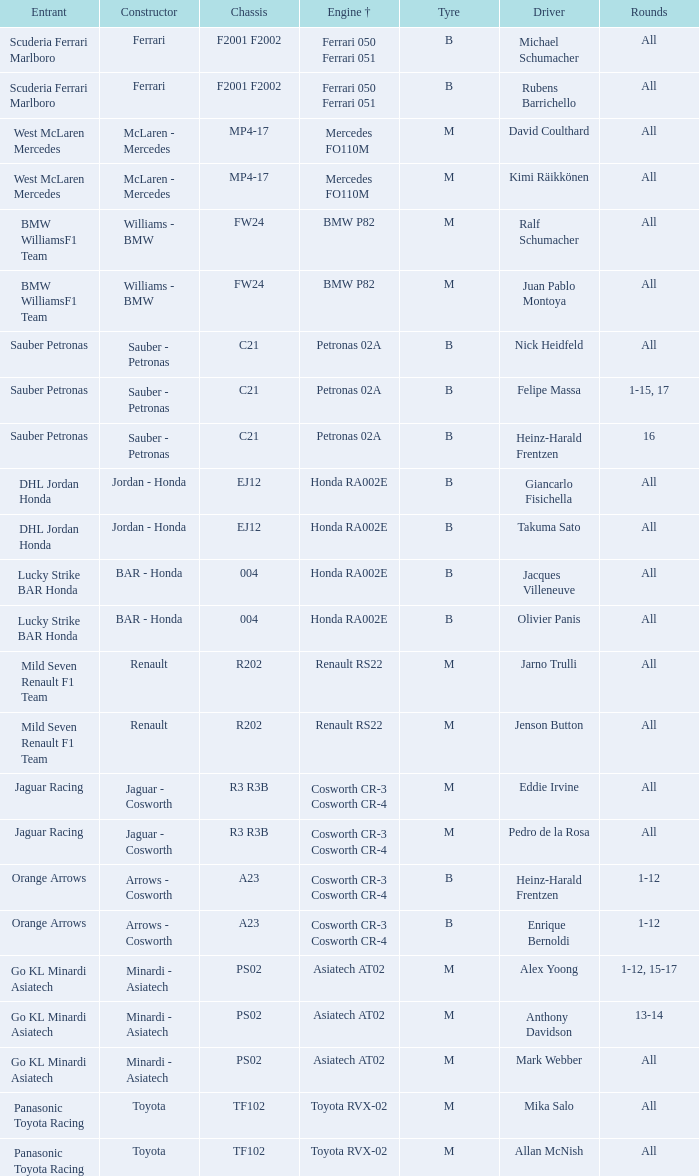What is the tyre when the engine is asiatech at02 and the driver is alex yoong? M. 